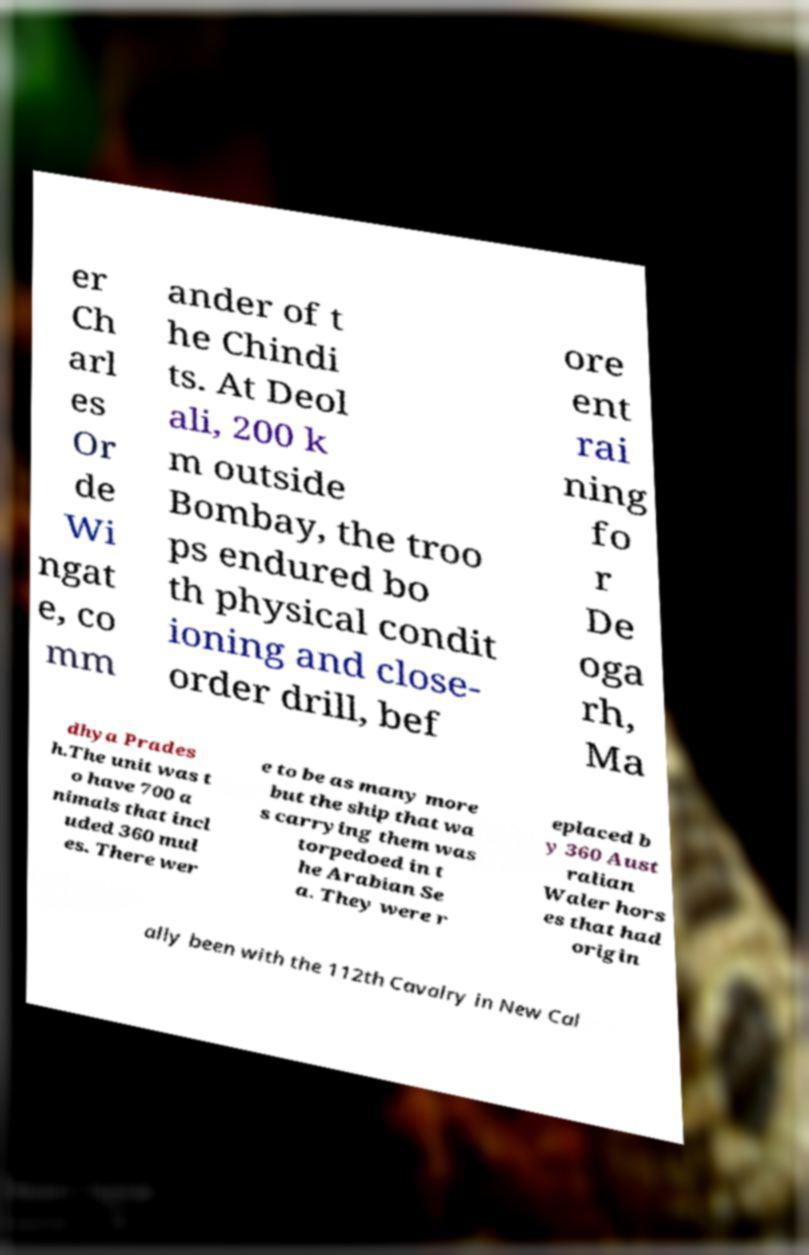I need the written content from this picture converted into text. Can you do that? er Ch arl es Or de Wi ngat e, co mm ander of t he Chindi ts. At Deol ali, 200 k m outside Bombay, the troo ps endured bo th physical condit ioning and close- order drill, bef ore ent rai ning fo r De oga rh, Ma dhya Prades h.The unit was t o have 700 a nimals that incl uded 360 mul es. There wer e to be as many more but the ship that wa s carrying them was torpedoed in t he Arabian Se a. They were r eplaced b y 360 Aust ralian Waler hors es that had origin ally been with the 112th Cavalry in New Cal 